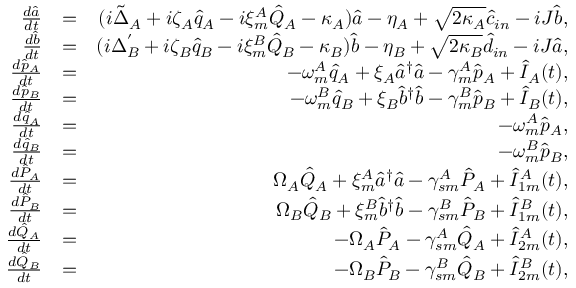<formula> <loc_0><loc_0><loc_500><loc_500>\begin{array} { r l r } { \frac { d \hat { a } } { d t } } & { = } & { ( i \tilde { \Delta } _ { A } + i \zeta _ { A } \hat { q } _ { A } - i \xi _ { m } ^ { A } \hat { Q } _ { A } - \kappa _ { A } ) \hat { a } - \eta _ { A } + \sqrt { 2 \kappa _ { A } } \hat { c } _ { i n } - i J \hat { b } , } \\ { \frac { d \hat { b } } { d t } } & { = } & { ( i \Delta _ { B } ^ { ^ { \prime } } + i \zeta _ { B } \hat { q } _ { B } - i \xi _ { m } ^ { B } \hat { Q } _ { B } - \kappa _ { B } ) \hat { b } - \eta _ { B } + \sqrt { 2 \kappa _ { B } } \hat { d } _ { i n } - i J \hat { a } , } \\ { \frac { d \hat { p } _ { A } } { d t } } & { = } & { - \omega _ { m } ^ { A } \hat { q } _ { A } + \xi _ { A } \hat { a } ^ { \dagger } \hat { a } - \gamma _ { m } ^ { A } \hat { p } _ { A } + \hat { I } _ { A } ( t ) , } \\ { \frac { d \hat { p } _ { B } } { d t } } & { = } & { - \omega _ { m } ^ { B } \hat { q } _ { B } + \xi _ { B } \hat { b } ^ { \dagger } \hat { b } - \gamma _ { m } ^ { B } \hat { p } _ { B } + \hat { I } _ { B } ( t ) , } \\ { \frac { d \hat { q } _ { A } } { d t } } & { = } & { - \omega _ { m } ^ { A } \hat { p } _ { A } , } \\ { \frac { d \hat { q } _ { B } } { d t } } & { = } & { - \omega _ { m } ^ { B } \hat { p } _ { B } , } \\ { \frac { d \hat { P } _ { A } } { d t } } & { = } & { \Omega _ { A } \hat { Q } _ { A } + \xi _ { m } ^ { A } \hat { a } ^ { \dagger } \hat { a } - \gamma _ { s m } ^ { A } \hat { P } _ { A } + \hat { I } _ { 1 m } ^ { A } ( t ) , } \\ { \frac { d \hat { P } _ { B } } { d t } } & { = } & { \Omega _ { B } \hat { Q } _ { B } + \xi _ { m } ^ { B } \hat { b } ^ { \dagger } \hat { b } - \gamma _ { s m } ^ { B } \hat { P } _ { B } + \hat { I } _ { 1 m } ^ { B } ( t ) , } \\ { \frac { d \hat { Q } _ { A } } { d t } } & { = } & { - \Omega _ { A } \hat { P } _ { A } - \gamma _ { s m } ^ { A } \hat { Q } _ { A } + \hat { I } _ { 2 m } ^ { A } ( t ) , } \\ { \frac { d \hat { Q } _ { B } } { d t } } & { = } & { - \Omega _ { B } \hat { P } _ { B } - \gamma _ { s m } ^ { B } \hat { Q } _ { B } + \hat { I } _ { 2 m } ^ { B } ( t ) , } \end{array}</formula> 